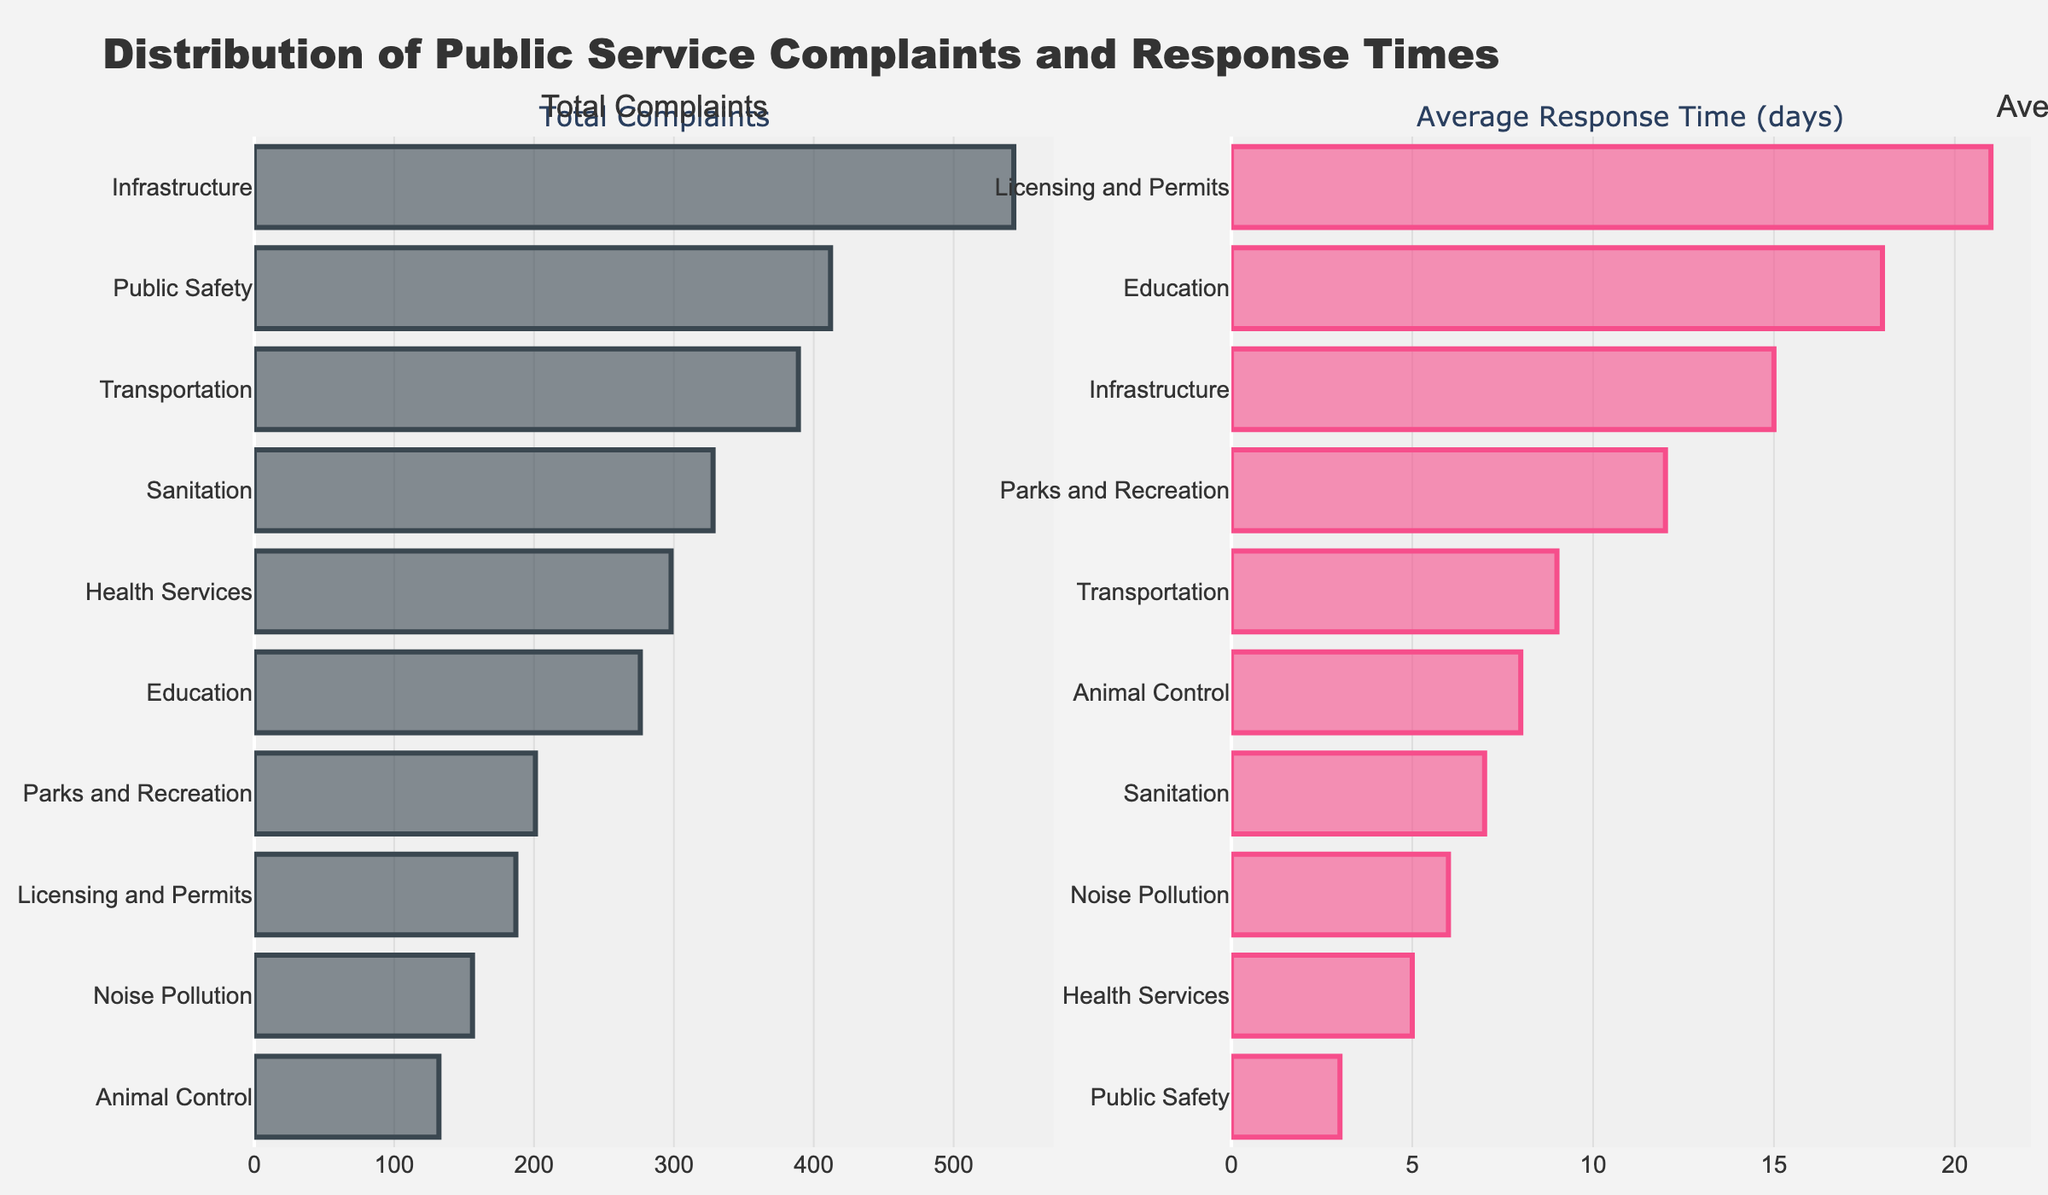What's the category with the highest number of complaints? To find the category with the highest number of complaints, look at the left subplot which shows the "Total Complaints" by category. The longest bar represents the category with the highest number.
Answer: Infrastructure Which category has the shortest average response time? To determine the category with the shortest average response time, look at the right subplot which shows "Average Response Time (days)" by category. The shortest bar indicates the category with the shortest response time.
Answer: Public Safety What's the total number of complaints for the categories Parks and Recreation and Transportation combined? Sum the "Total Complaints" for both categories by looking at the length of the bars in the "Total Complaints" subplot. Parks and Recreation has 201 complaints and Transportation has 389 complaints. The total is 201 + 389.
Answer: 590 How does the average response time for Licensing and Permits compare to that for Sanitation? Compare the lengths of the bars for both categories in the "Average Response Time (days)" subplot. Licensing and Permits has a response time of 21 days, while Sanitation has a response time of 7 days. Licensing and Permits has a longer response time than Sanitation.
Answer: Licensing and Permits has a longer response time What is the difference in average response time between the category with the highest and lowest response times? Identify the highest and lowest response times from the "Average Response Time (days)" subplot. Education has the highest response time of 18 days, and Public Safety has the shortest with 3 days. The difference is 18 - 3.
Answer: 15 days Which category has fewer complaints than Health Services but a longer average response time? Health Services has 298 complaints and a response time of 5 days. Look for categories with fewer complaints and a longer response time than 5 days. Licensing and Permits fits this criterion (187 complaints and 21 days).
Answer: Licensing and Permits In which subplot are the bars for Noise Pollution and Animal Control located next to each other? Check which plot shows the positions of the bars for Noise Pollution and Animal Control. In the "Total Complaints" subplot, these two bars are adjacent to each other in the sorted order of categories.
Answer: Total Complaints What trend can you identify between the categories with the fewest and most complaints in terms of response time? Categories with fewer complaints (Noise Pollution and Animal Control) tend to have shorter bars in the "Total Complaints" subplot compared to those with more complaints (Infrastructure). Both shorter and longer response times are observed across categories.
Answer: Mixed trend Which category has a response time close to 10 days? Look at the bars' lengths in the "Average Response Time (days)" subplot and identify which one is close to 10 days. Transportation has a response time of 9 days which is close to 10 days.
Answer: Transportation 